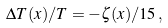<formula> <loc_0><loc_0><loc_500><loc_500>\Delta T ( x ) / T = - \zeta ( x ) / 1 5 \, ,</formula> 